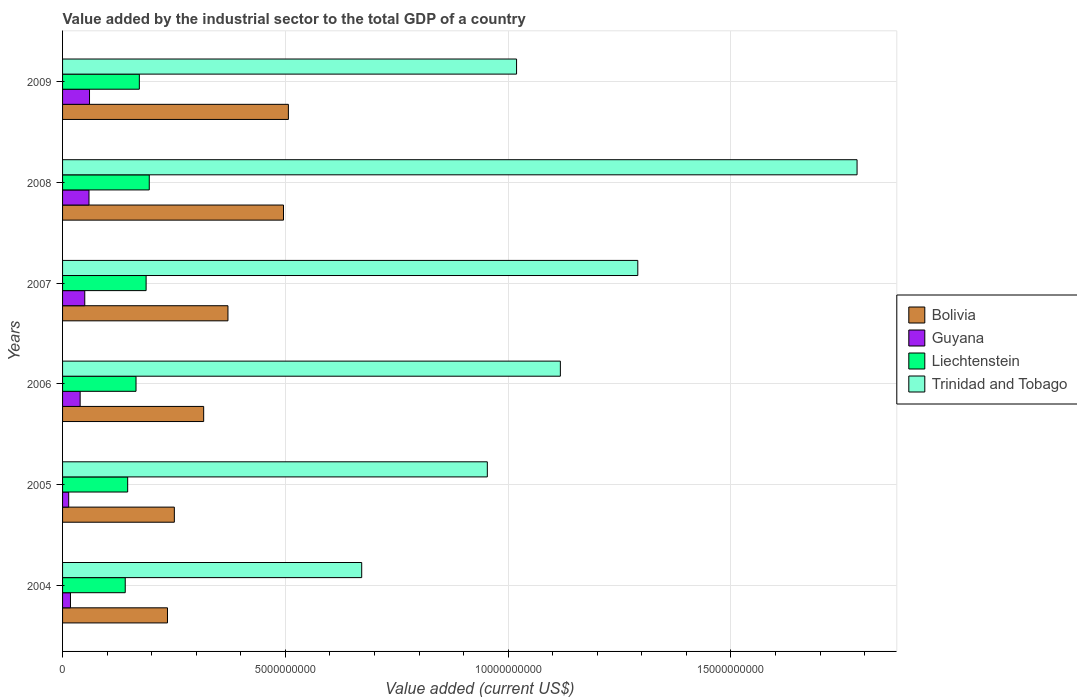How many different coloured bars are there?
Your response must be concise. 4. How many groups of bars are there?
Keep it short and to the point. 6. Are the number of bars per tick equal to the number of legend labels?
Your response must be concise. Yes. How many bars are there on the 4th tick from the bottom?
Make the answer very short. 4. What is the value added by the industrial sector to the total GDP in Guyana in 2008?
Keep it short and to the point. 5.93e+08. Across all years, what is the maximum value added by the industrial sector to the total GDP in Trinidad and Tobago?
Your answer should be very brief. 1.78e+1. Across all years, what is the minimum value added by the industrial sector to the total GDP in Guyana?
Give a very brief answer. 1.38e+08. In which year was the value added by the industrial sector to the total GDP in Trinidad and Tobago minimum?
Offer a very short reply. 2004. What is the total value added by the industrial sector to the total GDP in Guyana in the graph?
Offer a terse response. 2.41e+09. What is the difference between the value added by the industrial sector to the total GDP in Bolivia in 2004 and that in 2007?
Provide a succinct answer. -1.36e+09. What is the difference between the value added by the industrial sector to the total GDP in Liechtenstein in 2008 and the value added by the industrial sector to the total GDP in Trinidad and Tobago in 2007?
Offer a terse response. -1.10e+1. What is the average value added by the industrial sector to the total GDP in Trinidad and Tobago per year?
Ensure brevity in your answer.  1.14e+1. In the year 2009, what is the difference between the value added by the industrial sector to the total GDP in Trinidad and Tobago and value added by the industrial sector to the total GDP in Bolivia?
Your answer should be compact. 5.12e+09. In how many years, is the value added by the industrial sector to the total GDP in Bolivia greater than 14000000000 US$?
Offer a very short reply. 0. What is the ratio of the value added by the industrial sector to the total GDP in Guyana in 2008 to that in 2009?
Ensure brevity in your answer.  0.98. Is the difference between the value added by the industrial sector to the total GDP in Trinidad and Tobago in 2007 and 2009 greater than the difference between the value added by the industrial sector to the total GDP in Bolivia in 2007 and 2009?
Your answer should be compact. Yes. What is the difference between the highest and the second highest value added by the industrial sector to the total GDP in Guyana?
Your response must be concise. 1.15e+07. What is the difference between the highest and the lowest value added by the industrial sector to the total GDP in Guyana?
Ensure brevity in your answer.  4.67e+08. In how many years, is the value added by the industrial sector to the total GDP in Guyana greater than the average value added by the industrial sector to the total GDP in Guyana taken over all years?
Your answer should be very brief. 3. Is the sum of the value added by the industrial sector to the total GDP in Trinidad and Tobago in 2004 and 2007 greater than the maximum value added by the industrial sector to the total GDP in Guyana across all years?
Offer a terse response. Yes. What does the 1st bar from the top in 2008 represents?
Your answer should be very brief. Trinidad and Tobago. What does the 2nd bar from the bottom in 2004 represents?
Offer a terse response. Guyana. Is it the case that in every year, the sum of the value added by the industrial sector to the total GDP in Bolivia and value added by the industrial sector to the total GDP in Guyana is greater than the value added by the industrial sector to the total GDP in Liechtenstein?
Offer a terse response. Yes. What is the difference between two consecutive major ticks on the X-axis?
Provide a short and direct response. 5.00e+09. Does the graph contain any zero values?
Ensure brevity in your answer.  No. Does the graph contain grids?
Your answer should be compact. Yes. What is the title of the graph?
Provide a succinct answer. Value added by the industrial sector to the total GDP of a country. Does "Madagascar" appear as one of the legend labels in the graph?
Provide a succinct answer. No. What is the label or title of the X-axis?
Provide a succinct answer. Value added (current US$). What is the Value added (current US$) of Bolivia in 2004?
Offer a very short reply. 2.35e+09. What is the Value added (current US$) of Guyana in 2004?
Offer a terse response. 1.78e+08. What is the Value added (current US$) in Liechtenstein in 2004?
Ensure brevity in your answer.  1.41e+09. What is the Value added (current US$) of Trinidad and Tobago in 2004?
Make the answer very short. 6.71e+09. What is the Value added (current US$) of Bolivia in 2005?
Provide a succinct answer. 2.51e+09. What is the Value added (current US$) in Guyana in 2005?
Your answer should be very brief. 1.38e+08. What is the Value added (current US$) in Liechtenstein in 2005?
Provide a succinct answer. 1.46e+09. What is the Value added (current US$) in Trinidad and Tobago in 2005?
Provide a short and direct response. 9.53e+09. What is the Value added (current US$) of Bolivia in 2006?
Offer a very short reply. 3.17e+09. What is the Value added (current US$) of Guyana in 2006?
Provide a succinct answer. 3.94e+08. What is the Value added (current US$) of Liechtenstein in 2006?
Provide a succinct answer. 1.65e+09. What is the Value added (current US$) in Trinidad and Tobago in 2006?
Give a very brief answer. 1.12e+1. What is the Value added (current US$) of Bolivia in 2007?
Give a very brief answer. 3.71e+09. What is the Value added (current US$) of Guyana in 2007?
Your answer should be very brief. 4.98e+08. What is the Value added (current US$) of Liechtenstein in 2007?
Ensure brevity in your answer.  1.88e+09. What is the Value added (current US$) in Trinidad and Tobago in 2007?
Give a very brief answer. 1.29e+1. What is the Value added (current US$) in Bolivia in 2008?
Your answer should be compact. 4.96e+09. What is the Value added (current US$) of Guyana in 2008?
Offer a very short reply. 5.93e+08. What is the Value added (current US$) of Liechtenstein in 2008?
Keep it short and to the point. 1.95e+09. What is the Value added (current US$) in Trinidad and Tobago in 2008?
Make the answer very short. 1.78e+1. What is the Value added (current US$) in Bolivia in 2009?
Offer a terse response. 5.07e+09. What is the Value added (current US$) of Guyana in 2009?
Your answer should be compact. 6.05e+08. What is the Value added (current US$) of Liechtenstein in 2009?
Your answer should be very brief. 1.72e+09. What is the Value added (current US$) in Trinidad and Tobago in 2009?
Offer a very short reply. 1.02e+1. Across all years, what is the maximum Value added (current US$) of Bolivia?
Give a very brief answer. 5.07e+09. Across all years, what is the maximum Value added (current US$) of Guyana?
Your response must be concise. 6.05e+08. Across all years, what is the maximum Value added (current US$) of Liechtenstein?
Offer a terse response. 1.95e+09. Across all years, what is the maximum Value added (current US$) of Trinidad and Tobago?
Ensure brevity in your answer.  1.78e+1. Across all years, what is the minimum Value added (current US$) of Bolivia?
Offer a terse response. 2.35e+09. Across all years, what is the minimum Value added (current US$) in Guyana?
Your answer should be compact. 1.38e+08. Across all years, what is the minimum Value added (current US$) in Liechtenstein?
Provide a short and direct response. 1.41e+09. Across all years, what is the minimum Value added (current US$) of Trinidad and Tobago?
Your answer should be very brief. 6.71e+09. What is the total Value added (current US$) in Bolivia in the graph?
Give a very brief answer. 2.18e+1. What is the total Value added (current US$) in Guyana in the graph?
Your answer should be very brief. 2.41e+09. What is the total Value added (current US$) in Liechtenstein in the graph?
Offer a terse response. 1.01e+1. What is the total Value added (current US$) of Trinidad and Tobago in the graph?
Ensure brevity in your answer.  6.83e+1. What is the difference between the Value added (current US$) in Bolivia in 2004 and that in 2005?
Provide a short and direct response. -1.54e+08. What is the difference between the Value added (current US$) of Guyana in 2004 and that in 2005?
Your response must be concise. 4.00e+07. What is the difference between the Value added (current US$) in Liechtenstein in 2004 and that in 2005?
Ensure brevity in your answer.  -5.46e+07. What is the difference between the Value added (current US$) in Trinidad and Tobago in 2004 and that in 2005?
Provide a succinct answer. -2.82e+09. What is the difference between the Value added (current US$) of Bolivia in 2004 and that in 2006?
Make the answer very short. -8.12e+08. What is the difference between the Value added (current US$) in Guyana in 2004 and that in 2006?
Provide a short and direct response. -2.17e+08. What is the difference between the Value added (current US$) of Liechtenstein in 2004 and that in 2006?
Your response must be concise. -2.42e+08. What is the difference between the Value added (current US$) of Trinidad and Tobago in 2004 and that in 2006?
Offer a very short reply. -4.46e+09. What is the difference between the Value added (current US$) of Bolivia in 2004 and that in 2007?
Your response must be concise. -1.36e+09. What is the difference between the Value added (current US$) in Guyana in 2004 and that in 2007?
Keep it short and to the point. -3.21e+08. What is the difference between the Value added (current US$) of Liechtenstein in 2004 and that in 2007?
Offer a very short reply. -4.69e+08. What is the difference between the Value added (current US$) of Trinidad and Tobago in 2004 and that in 2007?
Provide a succinct answer. -6.20e+09. What is the difference between the Value added (current US$) in Bolivia in 2004 and that in 2008?
Give a very brief answer. -2.60e+09. What is the difference between the Value added (current US$) of Guyana in 2004 and that in 2008?
Provide a succinct answer. -4.16e+08. What is the difference between the Value added (current US$) in Liechtenstein in 2004 and that in 2008?
Offer a terse response. -5.39e+08. What is the difference between the Value added (current US$) of Trinidad and Tobago in 2004 and that in 2008?
Keep it short and to the point. -1.11e+1. What is the difference between the Value added (current US$) of Bolivia in 2004 and that in 2009?
Give a very brief answer. -2.71e+09. What is the difference between the Value added (current US$) in Guyana in 2004 and that in 2009?
Keep it short and to the point. -4.27e+08. What is the difference between the Value added (current US$) of Liechtenstein in 2004 and that in 2009?
Your answer should be compact. -3.17e+08. What is the difference between the Value added (current US$) of Trinidad and Tobago in 2004 and that in 2009?
Offer a very short reply. -3.48e+09. What is the difference between the Value added (current US$) in Bolivia in 2005 and that in 2006?
Keep it short and to the point. -6.58e+08. What is the difference between the Value added (current US$) of Guyana in 2005 and that in 2006?
Make the answer very short. -2.57e+08. What is the difference between the Value added (current US$) in Liechtenstein in 2005 and that in 2006?
Provide a succinct answer. -1.87e+08. What is the difference between the Value added (current US$) in Trinidad and Tobago in 2005 and that in 2006?
Ensure brevity in your answer.  -1.64e+09. What is the difference between the Value added (current US$) in Bolivia in 2005 and that in 2007?
Offer a very short reply. -1.20e+09. What is the difference between the Value added (current US$) in Guyana in 2005 and that in 2007?
Provide a short and direct response. -3.61e+08. What is the difference between the Value added (current US$) of Liechtenstein in 2005 and that in 2007?
Your response must be concise. -4.14e+08. What is the difference between the Value added (current US$) of Trinidad and Tobago in 2005 and that in 2007?
Provide a short and direct response. -3.38e+09. What is the difference between the Value added (current US$) in Bolivia in 2005 and that in 2008?
Your answer should be compact. -2.45e+09. What is the difference between the Value added (current US$) in Guyana in 2005 and that in 2008?
Provide a short and direct response. -4.56e+08. What is the difference between the Value added (current US$) in Liechtenstein in 2005 and that in 2008?
Give a very brief answer. -4.85e+08. What is the difference between the Value added (current US$) in Trinidad and Tobago in 2005 and that in 2008?
Your answer should be compact. -8.30e+09. What is the difference between the Value added (current US$) of Bolivia in 2005 and that in 2009?
Keep it short and to the point. -2.56e+09. What is the difference between the Value added (current US$) of Guyana in 2005 and that in 2009?
Offer a terse response. -4.67e+08. What is the difference between the Value added (current US$) of Liechtenstein in 2005 and that in 2009?
Make the answer very short. -2.62e+08. What is the difference between the Value added (current US$) of Trinidad and Tobago in 2005 and that in 2009?
Your answer should be compact. -6.56e+08. What is the difference between the Value added (current US$) in Bolivia in 2006 and that in 2007?
Keep it short and to the point. -5.45e+08. What is the difference between the Value added (current US$) of Guyana in 2006 and that in 2007?
Make the answer very short. -1.04e+08. What is the difference between the Value added (current US$) in Liechtenstein in 2006 and that in 2007?
Make the answer very short. -2.27e+08. What is the difference between the Value added (current US$) in Trinidad and Tobago in 2006 and that in 2007?
Your answer should be compact. -1.74e+09. What is the difference between the Value added (current US$) of Bolivia in 2006 and that in 2008?
Offer a very short reply. -1.79e+09. What is the difference between the Value added (current US$) in Guyana in 2006 and that in 2008?
Ensure brevity in your answer.  -1.99e+08. What is the difference between the Value added (current US$) of Liechtenstein in 2006 and that in 2008?
Offer a very short reply. -2.97e+08. What is the difference between the Value added (current US$) of Trinidad and Tobago in 2006 and that in 2008?
Ensure brevity in your answer.  -6.66e+09. What is the difference between the Value added (current US$) in Bolivia in 2006 and that in 2009?
Your answer should be compact. -1.90e+09. What is the difference between the Value added (current US$) of Guyana in 2006 and that in 2009?
Provide a short and direct response. -2.10e+08. What is the difference between the Value added (current US$) in Liechtenstein in 2006 and that in 2009?
Offer a very short reply. -7.45e+07. What is the difference between the Value added (current US$) of Trinidad and Tobago in 2006 and that in 2009?
Your answer should be very brief. 9.83e+08. What is the difference between the Value added (current US$) in Bolivia in 2007 and that in 2008?
Give a very brief answer. -1.25e+09. What is the difference between the Value added (current US$) of Guyana in 2007 and that in 2008?
Keep it short and to the point. -9.48e+07. What is the difference between the Value added (current US$) in Liechtenstein in 2007 and that in 2008?
Offer a terse response. -7.07e+07. What is the difference between the Value added (current US$) in Trinidad and Tobago in 2007 and that in 2008?
Your response must be concise. -4.92e+09. What is the difference between the Value added (current US$) in Bolivia in 2007 and that in 2009?
Ensure brevity in your answer.  -1.36e+09. What is the difference between the Value added (current US$) of Guyana in 2007 and that in 2009?
Ensure brevity in your answer.  -1.06e+08. What is the difference between the Value added (current US$) of Liechtenstein in 2007 and that in 2009?
Make the answer very short. 1.52e+08. What is the difference between the Value added (current US$) of Trinidad and Tobago in 2007 and that in 2009?
Your answer should be very brief. 2.72e+09. What is the difference between the Value added (current US$) in Bolivia in 2008 and that in 2009?
Offer a terse response. -1.10e+08. What is the difference between the Value added (current US$) of Guyana in 2008 and that in 2009?
Your response must be concise. -1.15e+07. What is the difference between the Value added (current US$) in Liechtenstein in 2008 and that in 2009?
Make the answer very short. 2.23e+08. What is the difference between the Value added (current US$) of Trinidad and Tobago in 2008 and that in 2009?
Your response must be concise. 7.64e+09. What is the difference between the Value added (current US$) in Bolivia in 2004 and the Value added (current US$) in Guyana in 2005?
Provide a succinct answer. 2.22e+09. What is the difference between the Value added (current US$) in Bolivia in 2004 and the Value added (current US$) in Liechtenstein in 2005?
Offer a terse response. 8.94e+08. What is the difference between the Value added (current US$) in Bolivia in 2004 and the Value added (current US$) in Trinidad and Tobago in 2005?
Make the answer very short. -7.18e+09. What is the difference between the Value added (current US$) of Guyana in 2004 and the Value added (current US$) of Liechtenstein in 2005?
Provide a succinct answer. -1.28e+09. What is the difference between the Value added (current US$) of Guyana in 2004 and the Value added (current US$) of Trinidad and Tobago in 2005?
Provide a succinct answer. -9.36e+09. What is the difference between the Value added (current US$) in Liechtenstein in 2004 and the Value added (current US$) in Trinidad and Tobago in 2005?
Offer a terse response. -8.13e+09. What is the difference between the Value added (current US$) of Bolivia in 2004 and the Value added (current US$) of Guyana in 2006?
Your answer should be very brief. 1.96e+09. What is the difference between the Value added (current US$) of Bolivia in 2004 and the Value added (current US$) of Liechtenstein in 2006?
Keep it short and to the point. 7.06e+08. What is the difference between the Value added (current US$) in Bolivia in 2004 and the Value added (current US$) in Trinidad and Tobago in 2006?
Your response must be concise. -8.82e+09. What is the difference between the Value added (current US$) of Guyana in 2004 and the Value added (current US$) of Liechtenstein in 2006?
Provide a succinct answer. -1.47e+09. What is the difference between the Value added (current US$) of Guyana in 2004 and the Value added (current US$) of Trinidad and Tobago in 2006?
Give a very brief answer. -1.10e+1. What is the difference between the Value added (current US$) in Liechtenstein in 2004 and the Value added (current US$) in Trinidad and Tobago in 2006?
Make the answer very short. -9.77e+09. What is the difference between the Value added (current US$) of Bolivia in 2004 and the Value added (current US$) of Guyana in 2007?
Make the answer very short. 1.86e+09. What is the difference between the Value added (current US$) of Bolivia in 2004 and the Value added (current US$) of Liechtenstein in 2007?
Offer a very short reply. 4.80e+08. What is the difference between the Value added (current US$) in Bolivia in 2004 and the Value added (current US$) in Trinidad and Tobago in 2007?
Your answer should be very brief. -1.06e+1. What is the difference between the Value added (current US$) of Guyana in 2004 and the Value added (current US$) of Liechtenstein in 2007?
Make the answer very short. -1.70e+09. What is the difference between the Value added (current US$) in Guyana in 2004 and the Value added (current US$) in Trinidad and Tobago in 2007?
Provide a succinct answer. -1.27e+1. What is the difference between the Value added (current US$) of Liechtenstein in 2004 and the Value added (current US$) of Trinidad and Tobago in 2007?
Your answer should be very brief. -1.15e+1. What is the difference between the Value added (current US$) of Bolivia in 2004 and the Value added (current US$) of Guyana in 2008?
Provide a short and direct response. 1.76e+09. What is the difference between the Value added (current US$) of Bolivia in 2004 and the Value added (current US$) of Liechtenstein in 2008?
Your answer should be compact. 4.09e+08. What is the difference between the Value added (current US$) in Bolivia in 2004 and the Value added (current US$) in Trinidad and Tobago in 2008?
Your answer should be compact. -1.55e+1. What is the difference between the Value added (current US$) in Guyana in 2004 and the Value added (current US$) in Liechtenstein in 2008?
Your answer should be compact. -1.77e+09. What is the difference between the Value added (current US$) in Guyana in 2004 and the Value added (current US$) in Trinidad and Tobago in 2008?
Your answer should be compact. -1.77e+1. What is the difference between the Value added (current US$) in Liechtenstein in 2004 and the Value added (current US$) in Trinidad and Tobago in 2008?
Provide a short and direct response. -1.64e+1. What is the difference between the Value added (current US$) of Bolivia in 2004 and the Value added (current US$) of Guyana in 2009?
Your answer should be very brief. 1.75e+09. What is the difference between the Value added (current US$) in Bolivia in 2004 and the Value added (current US$) in Liechtenstein in 2009?
Offer a terse response. 6.32e+08. What is the difference between the Value added (current US$) in Bolivia in 2004 and the Value added (current US$) in Trinidad and Tobago in 2009?
Your response must be concise. -7.83e+09. What is the difference between the Value added (current US$) of Guyana in 2004 and the Value added (current US$) of Liechtenstein in 2009?
Keep it short and to the point. -1.55e+09. What is the difference between the Value added (current US$) of Guyana in 2004 and the Value added (current US$) of Trinidad and Tobago in 2009?
Your answer should be compact. -1.00e+1. What is the difference between the Value added (current US$) in Liechtenstein in 2004 and the Value added (current US$) in Trinidad and Tobago in 2009?
Offer a terse response. -8.78e+09. What is the difference between the Value added (current US$) in Bolivia in 2005 and the Value added (current US$) in Guyana in 2006?
Ensure brevity in your answer.  2.11e+09. What is the difference between the Value added (current US$) of Bolivia in 2005 and the Value added (current US$) of Liechtenstein in 2006?
Offer a very short reply. 8.60e+08. What is the difference between the Value added (current US$) of Bolivia in 2005 and the Value added (current US$) of Trinidad and Tobago in 2006?
Make the answer very short. -8.66e+09. What is the difference between the Value added (current US$) of Guyana in 2005 and the Value added (current US$) of Liechtenstein in 2006?
Offer a terse response. -1.51e+09. What is the difference between the Value added (current US$) of Guyana in 2005 and the Value added (current US$) of Trinidad and Tobago in 2006?
Give a very brief answer. -1.10e+1. What is the difference between the Value added (current US$) in Liechtenstein in 2005 and the Value added (current US$) in Trinidad and Tobago in 2006?
Give a very brief answer. -9.71e+09. What is the difference between the Value added (current US$) in Bolivia in 2005 and the Value added (current US$) in Guyana in 2007?
Provide a short and direct response. 2.01e+09. What is the difference between the Value added (current US$) in Bolivia in 2005 and the Value added (current US$) in Liechtenstein in 2007?
Provide a short and direct response. 6.33e+08. What is the difference between the Value added (current US$) of Bolivia in 2005 and the Value added (current US$) of Trinidad and Tobago in 2007?
Your answer should be compact. -1.04e+1. What is the difference between the Value added (current US$) in Guyana in 2005 and the Value added (current US$) in Liechtenstein in 2007?
Your answer should be very brief. -1.74e+09. What is the difference between the Value added (current US$) in Guyana in 2005 and the Value added (current US$) in Trinidad and Tobago in 2007?
Your answer should be compact. -1.28e+1. What is the difference between the Value added (current US$) of Liechtenstein in 2005 and the Value added (current US$) of Trinidad and Tobago in 2007?
Make the answer very short. -1.14e+1. What is the difference between the Value added (current US$) in Bolivia in 2005 and the Value added (current US$) in Guyana in 2008?
Your answer should be compact. 1.92e+09. What is the difference between the Value added (current US$) of Bolivia in 2005 and the Value added (current US$) of Liechtenstein in 2008?
Your answer should be compact. 5.63e+08. What is the difference between the Value added (current US$) of Bolivia in 2005 and the Value added (current US$) of Trinidad and Tobago in 2008?
Your response must be concise. -1.53e+1. What is the difference between the Value added (current US$) in Guyana in 2005 and the Value added (current US$) in Liechtenstein in 2008?
Your response must be concise. -1.81e+09. What is the difference between the Value added (current US$) of Guyana in 2005 and the Value added (current US$) of Trinidad and Tobago in 2008?
Provide a short and direct response. -1.77e+1. What is the difference between the Value added (current US$) of Liechtenstein in 2005 and the Value added (current US$) of Trinidad and Tobago in 2008?
Your answer should be compact. -1.64e+1. What is the difference between the Value added (current US$) in Bolivia in 2005 and the Value added (current US$) in Guyana in 2009?
Your response must be concise. 1.90e+09. What is the difference between the Value added (current US$) of Bolivia in 2005 and the Value added (current US$) of Liechtenstein in 2009?
Provide a short and direct response. 7.85e+08. What is the difference between the Value added (current US$) of Bolivia in 2005 and the Value added (current US$) of Trinidad and Tobago in 2009?
Provide a short and direct response. -7.68e+09. What is the difference between the Value added (current US$) of Guyana in 2005 and the Value added (current US$) of Liechtenstein in 2009?
Your answer should be very brief. -1.59e+09. What is the difference between the Value added (current US$) of Guyana in 2005 and the Value added (current US$) of Trinidad and Tobago in 2009?
Offer a very short reply. -1.01e+1. What is the difference between the Value added (current US$) in Liechtenstein in 2005 and the Value added (current US$) in Trinidad and Tobago in 2009?
Your answer should be compact. -8.73e+09. What is the difference between the Value added (current US$) of Bolivia in 2006 and the Value added (current US$) of Guyana in 2007?
Your answer should be very brief. 2.67e+09. What is the difference between the Value added (current US$) of Bolivia in 2006 and the Value added (current US$) of Liechtenstein in 2007?
Ensure brevity in your answer.  1.29e+09. What is the difference between the Value added (current US$) in Bolivia in 2006 and the Value added (current US$) in Trinidad and Tobago in 2007?
Give a very brief answer. -9.74e+09. What is the difference between the Value added (current US$) in Guyana in 2006 and the Value added (current US$) in Liechtenstein in 2007?
Make the answer very short. -1.48e+09. What is the difference between the Value added (current US$) of Guyana in 2006 and the Value added (current US$) of Trinidad and Tobago in 2007?
Offer a terse response. -1.25e+1. What is the difference between the Value added (current US$) in Liechtenstein in 2006 and the Value added (current US$) in Trinidad and Tobago in 2007?
Offer a terse response. -1.13e+1. What is the difference between the Value added (current US$) in Bolivia in 2006 and the Value added (current US$) in Guyana in 2008?
Your response must be concise. 2.57e+09. What is the difference between the Value added (current US$) in Bolivia in 2006 and the Value added (current US$) in Liechtenstein in 2008?
Keep it short and to the point. 1.22e+09. What is the difference between the Value added (current US$) in Bolivia in 2006 and the Value added (current US$) in Trinidad and Tobago in 2008?
Provide a short and direct response. -1.47e+1. What is the difference between the Value added (current US$) of Guyana in 2006 and the Value added (current US$) of Liechtenstein in 2008?
Provide a succinct answer. -1.55e+09. What is the difference between the Value added (current US$) of Guyana in 2006 and the Value added (current US$) of Trinidad and Tobago in 2008?
Your response must be concise. -1.74e+1. What is the difference between the Value added (current US$) in Liechtenstein in 2006 and the Value added (current US$) in Trinidad and Tobago in 2008?
Provide a short and direct response. -1.62e+1. What is the difference between the Value added (current US$) of Bolivia in 2006 and the Value added (current US$) of Guyana in 2009?
Your answer should be compact. 2.56e+09. What is the difference between the Value added (current US$) in Bolivia in 2006 and the Value added (current US$) in Liechtenstein in 2009?
Offer a very short reply. 1.44e+09. What is the difference between the Value added (current US$) of Bolivia in 2006 and the Value added (current US$) of Trinidad and Tobago in 2009?
Offer a very short reply. -7.02e+09. What is the difference between the Value added (current US$) of Guyana in 2006 and the Value added (current US$) of Liechtenstein in 2009?
Your answer should be compact. -1.33e+09. What is the difference between the Value added (current US$) of Guyana in 2006 and the Value added (current US$) of Trinidad and Tobago in 2009?
Provide a short and direct response. -9.79e+09. What is the difference between the Value added (current US$) in Liechtenstein in 2006 and the Value added (current US$) in Trinidad and Tobago in 2009?
Provide a succinct answer. -8.54e+09. What is the difference between the Value added (current US$) of Bolivia in 2007 and the Value added (current US$) of Guyana in 2008?
Keep it short and to the point. 3.12e+09. What is the difference between the Value added (current US$) of Bolivia in 2007 and the Value added (current US$) of Liechtenstein in 2008?
Ensure brevity in your answer.  1.77e+09. What is the difference between the Value added (current US$) in Bolivia in 2007 and the Value added (current US$) in Trinidad and Tobago in 2008?
Your answer should be very brief. -1.41e+1. What is the difference between the Value added (current US$) of Guyana in 2007 and the Value added (current US$) of Liechtenstein in 2008?
Provide a short and direct response. -1.45e+09. What is the difference between the Value added (current US$) in Guyana in 2007 and the Value added (current US$) in Trinidad and Tobago in 2008?
Your answer should be compact. -1.73e+1. What is the difference between the Value added (current US$) in Liechtenstein in 2007 and the Value added (current US$) in Trinidad and Tobago in 2008?
Provide a short and direct response. -1.60e+1. What is the difference between the Value added (current US$) of Bolivia in 2007 and the Value added (current US$) of Guyana in 2009?
Your answer should be very brief. 3.11e+09. What is the difference between the Value added (current US$) of Bolivia in 2007 and the Value added (current US$) of Liechtenstein in 2009?
Your answer should be very brief. 1.99e+09. What is the difference between the Value added (current US$) in Bolivia in 2007 and the Value added (current US$) in Trinidad and Tobago in 2009?
Keep it short and to the point. -6.48e+09. What is the difference between the Value added (current US$) of Guyana in 2007 and the Value added (current US$) of Liechtenstein in 2009?
Your answer should be very brief. -1.22e+09. What is the difference between the Value added (current US$) of Guyana in 2007 and the Value added (current US$) of Trinidad and Tobago in 2009?
Keep it short and to the point. -9.69e+09. What is the difference between the Value added (current US$) of Liechtenstein in 2007 and the Value added (current US$) of Trinidad and Tobago in 2009?
Your response must be concise. -8.31e+09. What is the difference between the Value added (current US$) in Bolivia in 2008 and the Value added (current US$) in Guyana in 2009?
Ensure brevity in your answer.  4.35e+09. What is the difference between the Value added (current US$) in Bolivia in 2008 and the Value added (current US$) in Liechtenstein in 2009?
Provide a succinct answer. 3.24e+09. What is the difference between the Value added (current US$) of Bolivia in 2008 and the Value added (current US$) of Trinidad and Tobago in 2009?
Your answer should be compact. -5.23e+09. What is the difference between the Value added (current US$) of Guyana in 2008 and the Value added (current US$) of Liechtenstein in 2009?
Keep it short and to the point. -1.13e+09. What is the difference between the Value added (current US$) of Guyana in 2008 and the Value added (current US$) of Trinidad and Tobago in 2009?
Make the answer very short. -9.60e+09. What is the difference between the Value added (current US$) of Liechtenstein in 2008 and the Value added (current US$) of Trinidad and Tobago in 2009?
Your response must be concise. -8.24e+09. What is the average Value added (current US$) in Bolivia per year?
Your answer should be very brief. 3.63e+09. What is the average Value added (current US$) in Guyana per year?
Offer a terse response. 4.01e+08. What is the average Value added (current US$) of Liechtenstein per year?
Provide a succinct answer. 1.68e+09. What is the average Value added (current US$) in Trinidad and Tobago per year?
Provide a succinct answer. 1.14e+1. In the year 2004, what is the difference between the Value added (current US$) of Bolivia and Value added (current US$) of Guyana?
Give a very brief answer. 2.18e+09. In the year 2004, what is the difference between the Value added (current US$) in Bolivia and Value added (current US$) in Liechtenstein?
Your response must be concise. 9.48e+08. In the year 2004, what is the difference between the Value added (current US$) in Bolivia and Value added (current US$) in Trinidad and Tobago?
Your answer should be compact. -4.36e+09. In the year 2004, what is the difference between the Value added (current US$) in Guyana and Value added (current US$) in Liechtenstein?
Keep it short and to the point. -1.23e+09. In the year 2004, what is the difference between the Value added (current US$) in Guyana and Value added (current US$) in Trinidad and Tobago?
Make the answer very short. -6.54e+09. In the year 2004, what is the difference between the Value added (current US$) of Liechtenstein and Value added (current US$) of Trinidad and Tobago?
Your answer should be compact. -5.31e+09. In the year 2005, what is the difference between the Value added (current US$) in Bolivia and Value added (current US$) in Guyana?
Make the answer very short. 2.37e+09. In the year 2005, what is the difference between the Value added (current US$) in Bolivia and Value added (current US$) in Liechtenstein?
Offer a very short reply. 1.05e+09. In the year 2005, what is the difference between the Value added (current US$) of Bolivia and Value added (current US$) of Trinidad and Tobago?
Your answer should be very brief. -7.02e+09. In the year 2005, what is the difference between the Value added (current US$) in Guyana and Value added (current US$) in Liechtenstein?
Make the answer very short. -1.32e+09. In the year 2005, what is the difference between the Value added (current US$) in Guyana and Value added (current US$) in Trinidad and Tobago?
Ensure brevity in your answer.  -9.40e+09. In the year 2005, what is the difference between the Value added (current US$) of Liechtenstein and Value added (current US$) of Trinidad and Tobago?
Offer a very short reply. -8.07e+09. In the year 2006, what is the difference between the Value added (current US$) in Bolivia and Value added (current US$) in Guyana?
Your answer should be very brief. 2.77e+09. In the year 2006, what is the difference between the Value added (current US$) of Bolivia and Value added (current US$) of Liechtenstein?
Your answer should be very brief. 1.52e+09. In the year 2006, what is the difference between the Value added (current US$) of Bolivia and Value added (current US$) of Trinidad and Tobago?
Make the answer very short. -8.01e+09. In the year 2006, what is the difference between the Value added (current US$) in Guyana and Value added (current US$) in Liechtenstein?
Your response must be concise. -1.25e+09. In the year 2006, what is the difference between the Value added (current US$) in Guyana and Value added (current US$) in Trinidad and Tobago?
Your response must be concise. -1.08e+1. In the year 2006, what is the difference between the Value added (current US$) in Liechtenstein and Value added (current US$) in Trinidad and Tobago?
Give a very brief answer. -9.52e+09. In the year 2007, what is the difference between the Value added (current US$) in Bolivia and Value added (current US$) in Guyana?
Provide a short and direct response. 3.21e+09. In the year 2007, what is the difference between the Value added (current US$) in Bolivia and Value added (current US$) in Liechtenstein?
Offer a terse response. 1.84e+09. In the year 2007, what is the difference between the Value added (current US$) of Bolivia and Value added (current US$) of Trinidad and Tobago?
Provide a succinct answer. -9.20e+09. In the year 2007, what is the difference between the Value added (current US$) in Guyana and Value added (current US$) in Liechtenstein?
Your answer should be very brief. -1.38e+09. In the year 2007, what is the difference between the Value added (current US$) in Guyana and Value added (current US$) in Trinidad and Tobago?
Provide a succinct answer. -1.24e+1. In the year 2007, what is the difference between the Value added (current US$) of Liechtenstein and Value added (current US$) of Trinidad and Tobago?
Offer a terse response. -1.10e+1. In the year 2008, what is the difference between the Value added (current US$) in Bolivia and Value added (current US$) in Guyana?
Keep it short and to the point. 4.37e+09. In the year 2008, what is the difference between the Value added (current US$) of Bolivia and Value added (current US$) of Liechtenstein?
Your response must be concise. 3.01e+09. In the year 2008, what is the difference between the Value added (current US$) of Bolivia and Value added (current US$) of Trinidad and Tobago?
Your answer should be very brief. -1.29e+1. In the year 2008, what is the difference between the Value added (current US$) in Guyana and Value added (current US$) in Liechtenstein?
Give a very brief answer. -1.35e+09. In the year 2008, what is the difference between the Value added (current US$) in Guyana and Value added (current US$) in Trinidad and Tobago?
Your response must be concise. -1.72e+1. In the year 2008, what is the difference between the Value added (current US$) of Liechtenstein and Value added (current US$) of Trinidad and Tobago?
Offer a very short reply. -1.59e+1. In the year 2009, what is the difference between the Value added (current US$) of Bolivia and Value added (current US$) of Guyana?
Your answer should be compact. 4.46e+09. In the year 2009, what is the difference between the Value added (current US$) of Bolivia and Value added (current US$) of Liechtenstein?
Your answer should be very brief. 3.35e+09. In the year 2009, what is the difference between the Value added (current US$) of Bolivia and Value added (current US$) of Trinidad and Tobago?
Ensure brevity in your answer.  -5.12e+09. In the year 2009, what is the difference between the Value added (current US$) in Guyana and Value added (current US$) in Liechtenstein?
Offer a terse response. -1.12e+09. In the year 2009, what is the difference between the Value added (current US$) of Guyana and Value added (current US$) of Trinidad and Tobago?
Offer a terse response. -9.58e+09. In the year 2009, what is the difference between the Value added (current US$) of Liechtenstein and Value added (current US$) of Trinidad and Tobago?
Ensure brevity in your answer.  -8.47e+09. What is the ratio of the Value added (current US$) in Bolivia in 2004 to that in 2005?
Offer a very short reply. 0.94. What is the ratio of the Value added (current US$) in Guyana in 2004 to that in 2005?
Offer a very short reply. 1.29. What is the ratio of the Value added (current US$) of Liechtenstein in 2004 to that in 2005?
Offer a terse response. 0.96. What is the ratio of the Value added (current US$) in Trinidad and Tobago in 2004 to that in 2005?
Ensure brevity in your answer.  0.7. What is the ratio of the Value added (current US$) of Bolivia in 2004 to that in 2006?
Give a very brief answer. 0.74. What is the ratio of the Value added (current US$) in Guyana in 2004 to that in 2006?
Keep it short and to the point. 0.45. What is the ratio of the Value added (current US$) in Liechtenstein in 2004 to that in 2006?
Your answer should be compact. 0.85. What is the ratio of the Value added (current US$) in Trinidad and Tobago in 2004 to that in 2006?
Give a very brief answer. 0.6. What is the ratio of the Value added (current US$) in Bolivia in 2004 to that in 2007?
Provide a short and direct response. 0.63. What is the ratio of the Value added (current US$) in Guyana in 2004 to that in 2007?
Make the answer very short. 0.36. What is the ratio of the Value added (current US$) in Liechtenstein in 2004 to that in 2007?
Ensure brevity in your answer.  0.75. What is the ratio of the Value added (current US$) in Trinidad and Tobago in 2004 to that in 2007?
Provide a succinct answer. 0.52. What is the ratio of the Value added (current US$) in Bolivia in 2004 to that in 2008?
Offer a very short reply. 0.47. What is the ratio of the Value added (current US$) in Guyana in 2004 to that in 2008?
Your answer should be compact. 0.3. What is the ratio of the Value added (current US$) in Liechtenstein in 2004 to that in 2008?
Your answer should be compact. 0.72. What is the ratio of the Value added (current US$) in Trinidad and Tobago in 2004 to that in 2008?
Keep it short and to the point. 0.38. What is the ratio of the Value added (current US$) of Bolivia in 2004 to that in 2009?
Offer a terse response. 0.46. What is the ratio of the Value added (current US$) in Guyana in 2004 to that in 2009?
Ensure brevity in your answer.  0.29. What is the ratio of the Value added (current US$) in Liechtenstein in 2004 to that in 2009?
Give a very brief answer. 0.82. What is the ratio of the Value added (current US$) of Trinidad and Tobago in 2004 to that in 2009?
Give a very brief answer. 0.66. What is the ratio of the Value added (current US$) in Bolivia in 2005 to that in 2006?
Your answer should be compact. 0.79. What is the ratio of the Value added (current US$) of Guyana in 2005 to that in 2006?
Give a very brief answer. 0.35. What is the ratio of the Value added (current US$) of Liechtenstein in 2005 to that in 2006?
Provide a succinct answer. 0.89. What is the ratio of the Value added (current US$) of Trinidad and Tobago in 2005 to that in 2006?
Make the answer very short. 0.85. What is the ratio of the Value added (current US$) of Bolivia in 2005 to that in 2007?
Give a very brief answer. 0.68. What is the ratio of the Value added (current US$) in Guyana in 2005 to that in 2007?
Keep it short and to the point. 0.28. What is the ratio of the Value added (current US$) in Liechtenstein in 2005 to that in 2007?
Give a very brief answer. 0.78. What is the ratio of the Value added (current US$) in Trinidad and Tobago in 2005 to that in 2007?
Provide a succinct answer. 0.74. What is the ratio of the Value added (current US$) in Bolivia in 2005 to that in 2008?
Your answer should be very brief. 0.51. What is the ratio of the Value added (current US$) in Guyana in 2005 to that in 2008?
Keep it short and to the point. 0.23. What is the ratio of the Value added (current US$) in Liechtenstein in 2005 to that in 2008?
Provide a short and direct response. 0.75. What is the ratio of the Value added (current US$) of Trinidad and Tobago in 2005 to that in 2008?
Offer a terse response. 0.53. What is the ratio of the Value added (current US$) in Bolivia in 2005 to that in 2009?
Make the answer very short. 0.49. What is the ratio of the Value added (current US$) of Guyana in 2005 to that in 2009?
Ensure brevity in your answer.  0.23. What is the ratio of the Value added (current US$) of Liechtenstein in 2005 to that in 2009?
Keep it short and to the point. 0.85. What is the ratio of the Value added (current US$) in Trinidad and Tobago in 2005 to that in 2009?
Provide a succinct answer. 0.94. What is the ratio of the Value added (current US$) of Bolivia in 2006 to that in 2007?
Your response must be concise. 0.85. What is the ratio of the Value added (current US$) of Guyana in 2006 to that in 2007?
Your answer should be compact. 0.79. What is the ratio of the Value added (current US$) of Liechtenstein in 2006 to that in 2007?
Provide a succinct answer. 0.88. What is the ratio of the Value added (current US$) in Trinidad and Tobago in 2006 to that in 2007?
Offer a terse response. 0.87. What is the ratio of the Value added (current US$) of Bolivia in 2006 to that in 2008?
Provide a succinct answer. 0.64. What is the ratio of the Value added (current US$) in Guyana in 2006 to that in 2008?
Your response must be concise. 0.66. What is the ratio of the Value added (current US$) of Liechtenstein in 2006 to that in 2008?
Provide a short and direct response. 0.85. What is the ratio of the Value added (current US$) in Trinidad and Tobago in 2006 to that in 2008?
Make the answer very short. 0.63. What is the ratio of the Value added (current US$) of Bolivia in 2006 to that in 2009?
Your answer should be very brief. 0.62. What is the ratio of the Value added (current US$) of Guyana in 2006 to that in 2009?
Offer a terse response. 0.65. What is the ratio of the Value added (current US$) in Liechtenstein in 2006 to that in 2009?
Keep it short and to the point. 0.96. What is the ratio of the Value added (current US$) of Trinidad and Tobago in 2006 to that in 2009?
Provide a short and direct response. 1.1. What is the ratio of the Value added (current US$) in Bolivia in 2007 to that in 2008?
Your answer should be compact. 0.75. What is the ratio of the Value added (current US$) of Guyana in 2007 to that in 2008?
Ensure brevity in your answer.  0.84. What is the ratio of the Value added (current US$) of Liechtenstein in 2007 to that in 2008?
Your answer should be very brief. 0.96. What is the ratio of the Value added (current US$) of Trinidad and Tobago in 2007 to that in 2008?
Offer a very short reply. 0.72. What is the ratio of the Value added (current US$) in Bolivia in 2007 to that in 2009?
Offer a terse response. 0.73. What is the ratio of the Value added (current US$) in Guyana in 2007 to that in 2009?
Offer a terse response. 0.82. What is the ratio of the Value added (current US$) in Liechtenstein in 2007 to that in 2009?
Offer a terse response. 1.09. What is the ratio of the Value added (current US$) in Trinidad and Tobago in 2007 to that in 2009?
Ensure brevity in your answer.  1.27. What is the ratio of the Value added (current US$) of Bolivia in 2008 to that in 2009?
Offer a terse response. 0.98. What is the ratio of the Value added (current US$) in Guyana in 2008 to that in 2009?
Ensure brevity in your answer.  0.98. What is the ratio of the Value added (current US$) of Liechtenstein in 2008 to that in 2009?
Provide a short and direct response. 1.13. What is the ratio of the Value added (current US$) of Trinidad and Tobago in 2008 to that in 2009?
Your response must be concise. 1.75. What is the difference between the highest and the second highest Value added (current US$) of Bolivia?
Provide a succinct answer. 1.10e+08. What is the difference between the highest and the second highest Value added (current US$) of Guyana?
Make the answer very short. 1.15e+07. What is the difference between the highest and the second highest Value added (current US$) of Liechtenstein?
Provide a succinct answer. 7.07e+07. What is the difference between the highest and the second highest Value added (current US$) of Trinidad and Tobago?
Keep it short and to the point. 4.92e+09. What is the difference between the highest and the lowest Value added (current US$) in Bolivia?
Keep it short and to the point. 2.71e+09. What is the difference between the highest and the lowest Value added (current US$) in Guyana?
Give a very brief answer. 4.67e+08. What is the difference between the highest and the lowest Value added (current US$) in Liechtenstein?
Your answer should be compact. 5.39e+08. What is the difference between the highest and the lowest Value added (current US$) in Trinidad and Tobago?
Keep it short and to the point. 1.11e+1. 